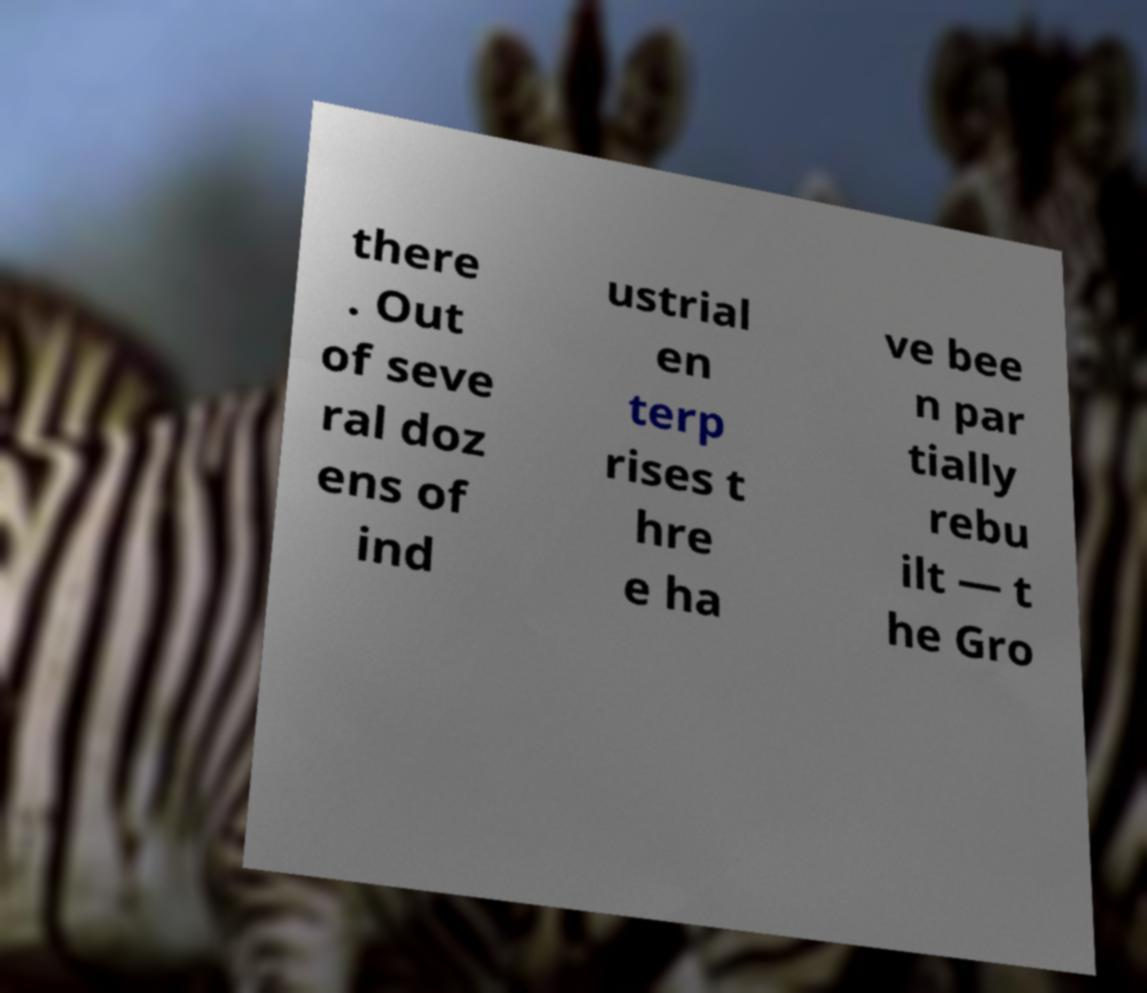Can you read and provide the text displayed in the image?This photo seems to have some interesting text. Can you extract and type it out for me? there . Out of seve ral doz ens of ind ustrial en terp rises t hre e ha ve bee n par tially rebu ilt — t he Gro 